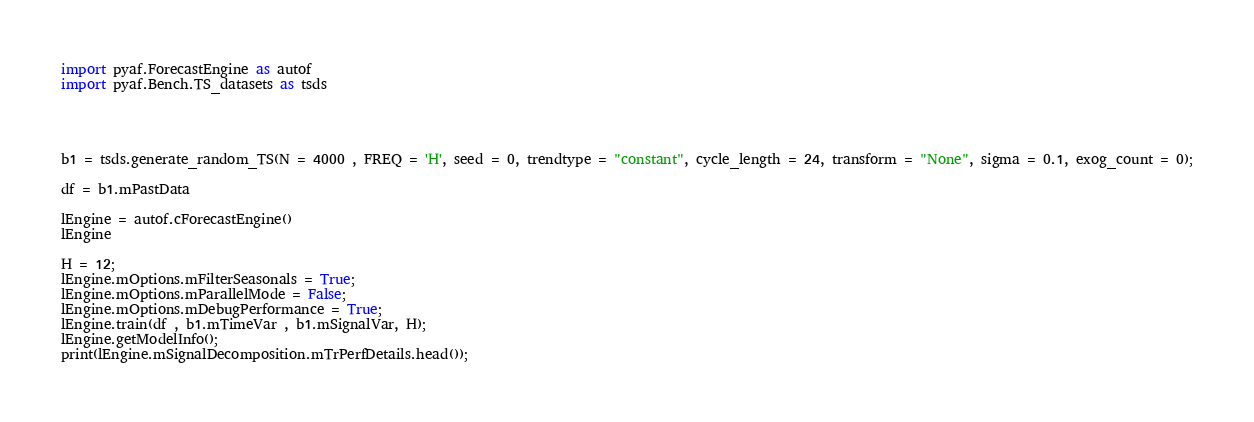<code> <loc_0><loc_0><loc_500><loc_500><_Python_>
import pyaf.ForecastEngine as autof
import pyaf.Bench.TS_datasets as tsds




b1 = tsds.generate_random_TS(N = 4000 , FREQ = 'H', seed = 0, trendtype = "constant", cycle_length = 24, transform = "None", sigma = 0.1, exog_count = 0);

df = b1.mPastData

lEngine = autof.cForecastEngine()
lEngine

H = 12;
lEngine.mOptions.mFilterSeasonals = True;
lEngine.mOptions.mParallelMode = False;
lEngine.mOptions.mDebugPerformance = True;
lEngine.train(df , b1.mTimeVar , b1.mSignalVar, H);
lEngine.getModelInfo();
print(lEngine.mSignalDecomposition.mTrPerfDetails.head());

</code> 